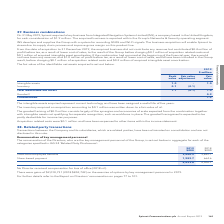According to Spirent Communications Plc's financial document, What were the gains on the exercise of options by key management personnel in 2019? According to the financial document, $2,010,731. The relevant text states: "There were gains of $2,010,731 (2018 $852,742) on the exercise of options by key management personnel in 2019...." Also, What is the share-based payment for 2019? According to the financial document, 1,982.7 (in thousands). The relevant text states: "Share-based payment 1,982.7 664.6..." Also, What are the categories specified in IAS 24 ‘Related Party Disclosures’ in the table? The document shows two values: Short-term employee benefits and Share-based payment. From the document: "Short-term employee benefits 3,540.9 3,842.1 Share-based payment 1,982.7 664.6..." Additionally, In which year was the amount of short-term employee benefits larger? According to the financial document, 2018. The relevant text states: "2019 2018..." Also, can you calculate: What was the change in the total remuneration of key management personnel? Based on the calculation: 5,523.6-4,506.7, the result is 1016.9 (in thousands). This is based on the information: "5,523.6 4,506.7 5,523.6 4,506.7..." The key data points involved are: 4,506.7, 5,523.6. Also, can you calculate: What was the percentage change in the total remuneration of key management personnel? To answer this question, I need to perform calculations using the financial data. The calculation is: (5,523.6-4,506.7)/4,506.7, which equals 22.56 (percentage). This is based on the information: "5,523.6 4,506.7 5,523.6 4,506.7..." The key data points involved are: 4,506.7, 5,523.6. 